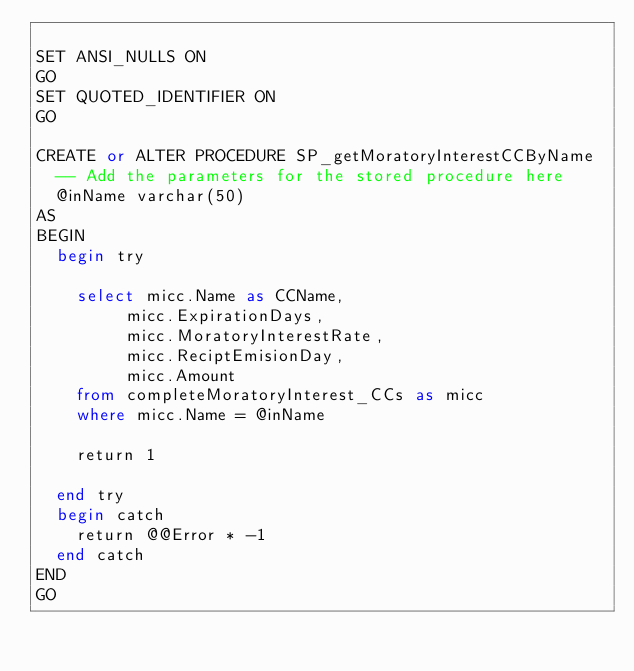<code> <loc_0><loc_0><loc_500><loc_500><_SQL_>
SET ANSI_NULLS ON
GO
SET QUOTED_IDENTIFIER ON
GO

CREATE or ALTER PROCEDURE SP_getMoratoryInterestCCByName
	-- Add the parameters for the stored procedure here
	@inName varchar(50)
AS
BEGIN
	begin try
		
		select micc.Name as CCName, 
			   micc.ExpirationDays,
			   micc.MoratoryInterestRate,
			   micc.ReciptEmisionDay,
			   micc.Amount
		from completeMoratoryInterest_CCs as micc
		where micc.Name = @inName

		return 1

	end try
	begin catch
		return @@Error * -1
	end catch
END
GO</code> 